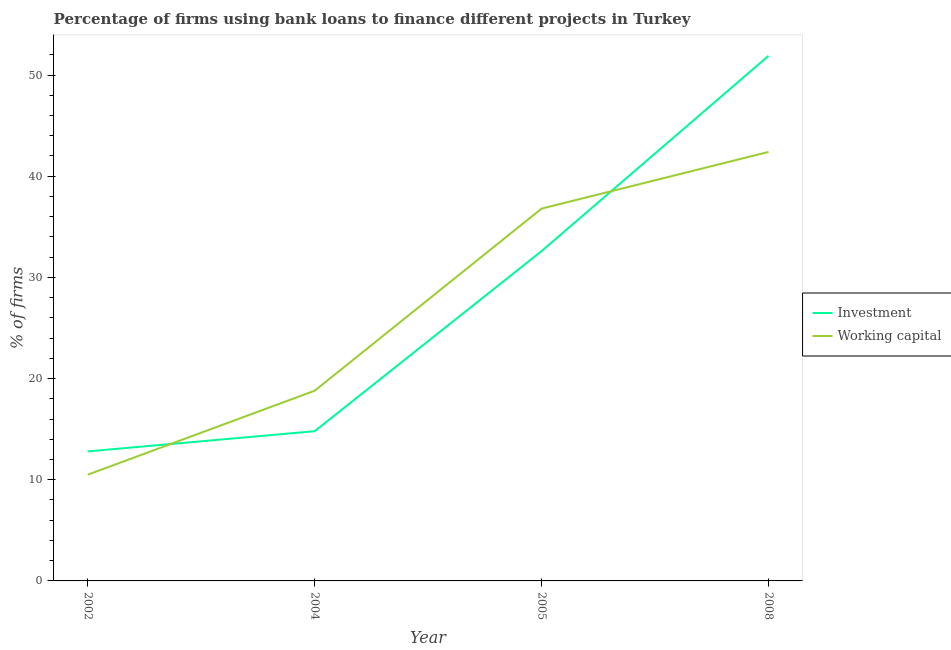Across all years, what is the maximum percentage of firms using banks to finance working capital?
Provide a short and direct response. 42.4. Across all years, what is the minimum percentage of firms using banks to finance working capital?
Offer a very short reply. 10.5. In which year was the percentage of firms using banks to finance working capital maximum?
Provide a short and direct response. 2008. In which year was the percentage of firms using banks to finance investment minimum?
Provide a succinct answer. 2002. What is the total percentage of firms using banks to finance working capital in the graph?
Make the answer very short. 108.5. What is the difference between the percentage of firms using banks to finance investment in 2004 and that in 2005?
Your response must be concise. -17.8. What is the average percentage of firms using banks to finance investment per year?
Your response must be concise. 28.02. In the year 2004, what is the difference between the percentage of firms using banks to finance working capital and percentage of firms using banks to finance investment?
Ensure brevity in your answer.  4. What is the ratio of the percentage of firms using banks to finance working capital in 2002 to that in 2005?
Offer a very short reply. 0.29. Is the difference between the percentage of firms using banks to finance working capital in 2005 and 2008 greater than the difference between the percentage of firms using banks to finance investment in 2005 and 2008?
Keep it short and to the point. Yes. What is the difference between the highest and the second highest percentage of firms using banks to finance working capital?
Give a very brief answer. 5.6. What is the difference between the highest and the lowest percentage of firms using banks to finance investment?
Your answer should be compact. 39.1. In how many years, is the percentage of firms using banks to finance investment greater than the average percentage of firms using banks to finance investment taken over all years?
Make the answer very short. 2. Is the sum of the percentage of firms using banks to finance working capital in 2005 and 2008 greater than the maximum percentage of firms using banks to finance investment across all years?
Make the answer very short. Yes. What is the difference between two consecutive major ticks on the Y-axis?
Your answer should be very brief. 10. Does the graph contain any zero values?
Keep it short and to the point. No. Does the graph contain grids?
Offer a very short reply. No. How many legend labels are there?
Make the answer very short. 2. What is the title of the graph?
Offer a terse response. Percentage of firms using bank loans to finance different projects in Turkey. Does "Adolescent fertility rate" appear as one of the legend labels in the graph?
Provide a short and direct response. No. What is the label or title of the X-axis?
Provide a short and direct response. Year. What is the label or title of the Y-axis?
Offer a terse response. % of firms. What is the % of firms of Investment in 2004?
Provide a succinct answer. 14.8. What is the % of firms of Investment in 2005?
Give a very brief answer. 32.6. What is the % of firms in Working capital in 2005?
Provide a succinct answer. 36.8. What is the % of firms in Investment in 2008?
Make the answer very short. 51.9. What is the % of firms of Working capital in 2008?
Provide a succinct answer. 42.4. Across all years, what is the maximum % of firms of Investment?
Provide a succinct answer. 51.9. Across all years, what is the maximum % of firms in Working capital?
Give a very brief answer. 42.4. What is the total % of firms in Investment in the graph?
Give a very brief answer. 112.1. What is the total % of firms in Working capital in the graph?
Ensure brevity in your answer.  108.5. What is the difference between the % of firms of Investment in 2002 and that in 2005?
Offer a terse response. -19.8. What is the difference between the % of firms in Working capital in 2002 and that in 2005?
Provide a short and direct response. -26.3. What is the difference between the % of firms in Investment in 2002 and that in 2008?
Give a very brief answer. -39.1. What is the difference between the % of firms of Working capital in 2002 and that in 2008?
Your answer should be compact. -31.9. What is the difference between the % of firms in Investment in 2004 and that in 2005?
Give a very brief answer. -17.8. What is the difference between the % of firms of Working capital in 2004 and that in 2005?
Ensure brevity in your answer.  -18. What is the difference between the % of firms of Investment in 2004 and that in 2008?
Ensure brevity in your answer.  -37.1. What is the difference between the % of firms of Working capital in 2004 and that in 2008?
Make the answer very short. -23.6. What is the difference between the % of firms in Investment in 2005 and that in 2008?
Provide a succinct answer. -19.3. What is the difference between the % of firms of Investment in 2002 and the % of firms of Working capital in 2004?
Offer a very short reply. -6. What is the difference between the % of firms of Investment in 2002 and the % of firms of Working capital in 2005?
Ensure brevity in your answer.  -24. What is the difference between the % of firms in Investment in 2002 and the % of firms in Working capital in 2008?
Make the answer very short. -29.6. What is the difference between the % of firms in Investment in 2004 and the % of firms in Working capital in 2008?
Your response must be concise. -27.6. What is the average % of firms of Investment per year?
Offer a very short reply. 28.02. What is the average % of firms of Working capital per year?
Your response must be concise. 27.12. In the year 2002, what is the difference between the % of firms of Investment and % of firms of Working capital?
Your response must be concise. 2.3. In the year 2005, what is the difference between the % of firms in Investment and % of firms in Working capital?
Your answer should be very brief. -4.2. What is the ratio of the % of firms of Investment in 2002 to that in 2004?
Your response must be concise. 0.86. What is the ratio of the % of firms of Working capital in 2002 to that in 2004?
Ensure brevity in your answer.  0.56. What is the ratio of the % of firms of Investment in 2002 to that in 2005?
Provide a short and direct response. 0.39. What is the ratio of the % of firms in Working capital in 2002 to that in 2005?
Your answer should be compact. 0.29. What is the ratio of the % of firms of Investment in 2002 to that in 2008?
Your answer should be compact. 0.25. What is the ratio of the % of firms of Working capital in 2002 to that in 2008?
Ensure brevity in your answer.  0.25. What is the ratio of the % of firms of Investment in 2004 to that in 2005?
Provide a succinct answer. 0.45. What is the ratio of the % of firms in Working capital in 2004 to that in 2005?
Provide a succinct answer. 0.51. What is the ratio of the % of firms of Investment in 2004 to that in 2008?
Your response must be concise. 0.29. What is the ratio of the % of firms in Working capital in 2004 to that in 2008?
Provide a succinct answer. 0.44. What is the ratio of the % of firms in Investment in 2005 to that in 2008?
Provide a succinct answer. 0.63. What is the ratio of the % of firms in Working capital in 2005 to that in 2008?
Offer a very short reply. 0.87. What is the difference between the highest and the second highest % of firms in Investment?
Make the answer very short. 19.3. What is the difference between the highest and the lowest % of firms of Investment?
Provide a succinct answer. 39.1. What is the difference between the highest and the lowest % of firms of Working capital?
Provide a short and direct response. 31.9. 